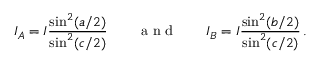<formula> <loc_0><loc_0><loc_500><loc_500>I _ { A } = I \frac { \sin ^ { 2 } ( a / 2 ) } { \sin ^ { 2 } ( c / 2 ) } \quad a n d \quad I _ { B } = I \frac { \sin ^ { 2 } ( b / 2 ) } { \sin ^ { 2 } ( c / 2 ) } \, .</formula> 